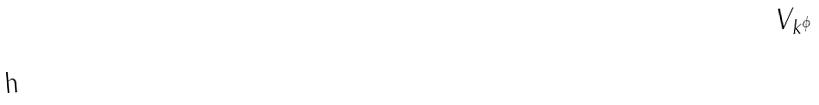Convert formula to latex. <formula><loc_0><loc_0><loc_500><loc_500>V _ { k ^ { \phi } }</formula> 